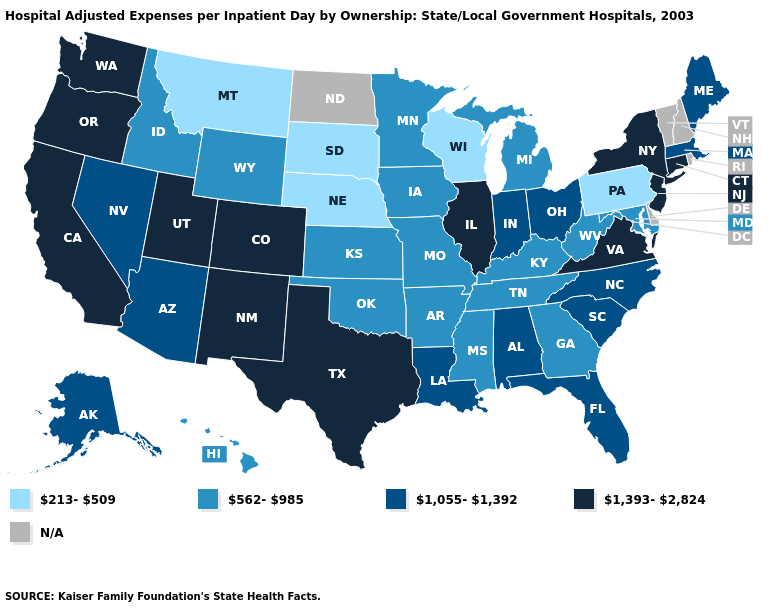Which states have the lowest value in the South?
Short answer required. Arkansas, Georgia, Kentucky, Maryland, Mississippi, Oklahoma, Tennessee, West Virginia. What is the value of Rhode Island?
Concise answer only. N/A. Among the states that border California , does Nevada have the lowest value?
Keep it brief. Yes. Does Arkansas have the highest value in the USA?
Write a very short answer. No. What is the highest value in the USA?
Concise answer only. 1,393-2,824. Name the states that have a value in the range 1,055-1,392?
Concise answer only. Alabama, Alaska, Arizona, Florida, Indiana, Louisiana, Maine, Massachusetts, Nevada, North Carolina, Ohio, South Carolina. Does the first symbol in the legend represent the smallest category?
Short answer required. Yes. Which states have the highest value in the USA?
Concise answer only. California, Colorado, Connecticut, Illinois, New Jersey, New Mexico, New York, Oregon, Texas, Utah, Virginia, Washington. Is the legend a continuous bar?
Short answer required. No. What is the value of North Carolina?
Answer briefly. 1,055-1,392. Which states hav the highest value in the Northeast?
Write a very short answer. Connecticut, New Jersey, New York. Does Nebraska have the lowest value in the USA?
Quick response, please. Yes. Which states have the highest value in the USA?
Short answer required. California, Colorado, Connecticut, Illinois, New Jersey, New Mexico, New York, Oregon, Texas, Utah, Virginia, Washington. Name the states that have a value in the range N/A?
Short answer required. Delaware, New Hampshire, North Dakota, Rhode Island, Vermont. Does Illinois have the highest value in the MidWest?
Give a very brief answer. Yes. 